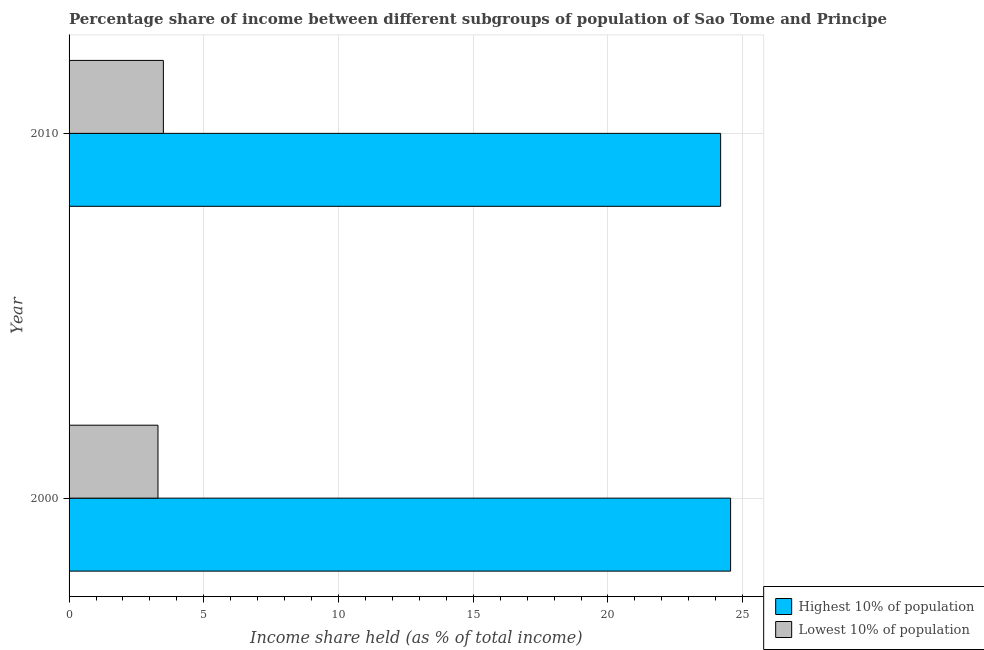How many different coloured bars are there?
Keep it short and to the point. 2. Are the number of bars per tick equal to the number of legend labels?
Ensure brevity in your answer.  Yes. In how many cases, is the number of bars for a given year not equal to the number of legend labels?
Your answer should be compact. 0. What is the income share held by lowest 10% of the population in 2000?
Provide a short and direct response. 3.3. Across all years, what is the maximum income share held by highest 10% of the population?
Give a very brief answer. 24.55. Across all years, what is the minimum income share held by highest 10% of the population?
Make the answer very short. 24.18. In which year was the income share held by highest 10% of the population maximum?
Your answer should be very brief. 2000. What is the difference between the income share held by highest 10% of the population in 2000 and that in 2010?
Provide a short and direct response. 0.37. What is the difference between the income share held by lowest 10% of the population in 2000 and the income share held by highest 10% of the population in 2010?
Make the answer very short. -20.88. What is the average income share held by lowest 10% of the population per year?
Your answer should be very brief. 3.4. In the year 2000, what is the difference between the income share held by lowest 10% of the population and income share held by highest 10% of the population?
Your response must be concise. -21.25. What is the ratio of the income share held by highest 10% of the population in 2000 to that in 2010?
Ensure brevity in your answer.  1.01. In how many years, is the income share held by lowest 10% of the population greater than the average income share held by lowest 10% of the population taken over all years?
Ensure brevity in your answer.  1. What does the 1st bar from the top in 2010 represents?
Your response must be concise. Lowest 10% of population. What does the 1st bar from the bottom in 2000 represents?
Your answer should be very brief. Highest 10% of population. How many bars are there?
Your answer should be very brief. 4. Are all the bars in the graph horizontal?
Your answer should be compact. Yes. Are the values on the major ticks of X-axis written in scientific E-notation?
Keep it short and to the point. No. Does the graph contain grids?
Make the answer very short. Yes. Where does the legend appear in the graph?
Your answer should be compact. Bottom right. How are the legend labels stacked?
Your answer should be compact. Vertical. What is the title of the graph?
Keep it short and to the point. Percentage share of income between different subgroups of population of Sao Tome and Principe. Does "Under-5(female)" appear as one of the legend labels in the graph?
Your response must be concise. No. What is the label or title of the X-axis?
Provide a short and direct response. Income share held (as % of total income). What is the label or title of the Y-axis?
Offer a very short reply. Year. What is the Income share held (as % of total income) in Highest 10% of population in 2000?
Give a very brief answer. 24.55. What is the Income share held (as % of total income) in Lowest 10% of population in 2000?
Your answer should be compact. 3.3. What is the Income share held (as % of total income) of Highest 10% of population in 2010?
Offer a terse response. 24.18. What is the Income share held (as % of total income) in Lowest 10% of population in 2010?
Your answer should be compact. 3.5. Across all years, what is the maximum Income share held (as % of total income) of Highest 10% of population?
Offer a very short reply. 24.55. Across all years, what is the minimum Income share held (as % of total income) in Highest 10% of population?
Keep it short and to the point. 24.18. What is the total Income share held (as % of total income) of Highest 10% of population in the graph?
Your response must be concise. 48.73. What is the total Income share held (as % of total income) in Lowest 10% of population in the graph?
Offer a very short reply. 6.8. What is the difference between the Income share held (as % of total income) in Highest 10% of population in 2000 and that in 2010?
Your answer should be very brief. 0.37. What is the difference between the Income share held (as % of total income) in Lowest 10% of population in 2000 and that in 2010?
Provide a short and direct response. -0.2. What is the difference between the Income share held (as % of total income) of Highest 10% of population in 2000 and the Income share held (as % of total income) of Lowest 10% of population in 2010?
Give a very brief answer. 21.05. What is the average Income share held (as % of total income) of Highest 10% of population per year?
Give a very brief answer. 24.36. What is the average Income share held (as % of total income) in Lowest 10% of population per year?
Your answer should be very brief. 3.4. In the year 2000, what is the difference between the Income share held (as % of total income) of Highest 10% of population and Income share held (as % of total income) of Lowest 10% of population?
Give a very brief answer. 21.25. In the year 2010, what is the difference between the Income share held (as % of total income) of Highest 10% of population and Income share held (as % of total income) of Lowest 10% of population?
Ensure brevity in your answer.  20.68. What is the ratio of the Income share held (as % of total income) of Highest 10% of population in 2000 to that in 2010?
Ensure brevity in your answer.  1.02. What is the ratio of the Income share held (as % of total income) in Lowest 10% of population in 2000 to that in 2010?
Offer a very short reply. 0.94. What is the difference between the highest and the second highest Income share held (as % of total income) of Highest 10% of population?
Your answer should be very brief. 0.37. What is the difference between the highest and the lowest Income share held (as % of total income) in Highest 10% of population?
Provide a short and direct response. 0.37. 